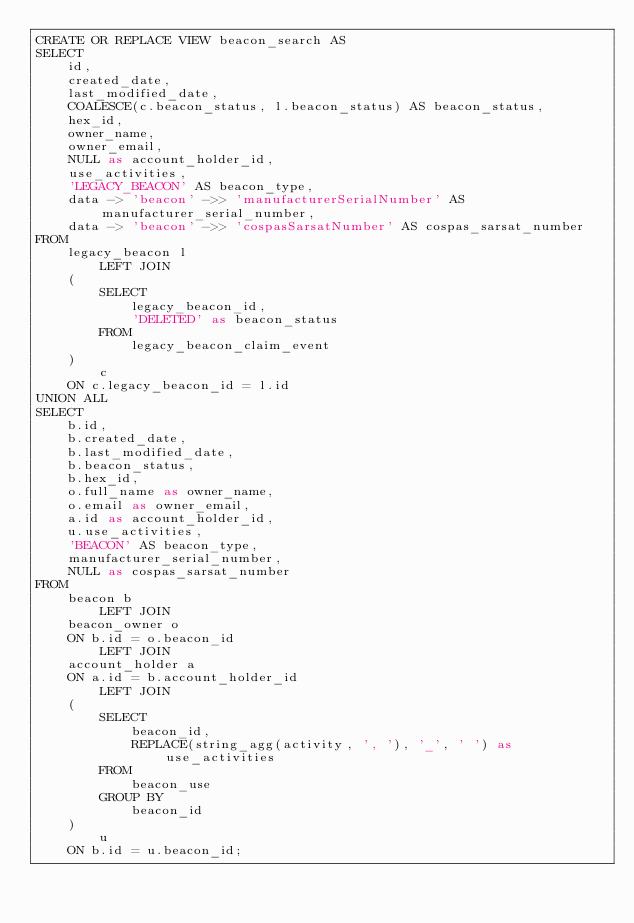<code> <loc_0><loc_0><loc_500><loc_500><_SQL_>CREATE OR REPLACE VIEW beacon_search AS
SELECT
    id,
    created_date,
    last_modified_date,
    COALESCE(c.beacon_status, l.beacon_status) AS beacon_status,
    hex_id,
    owner_name,
    owner_email,
    NULL as account_holder_id,
    use_activities,
    'LEGACY_BEACON' AS beacon_type,
    data -> 'beacon' ->> 'manufacturerSerialNumber' AS manufacturer_serial_number,
    data -> 'beacon' ->> 'cospasSarsatNumber' AS cospas_sarsat_number
FROM
    legacy_beacon l
        LEFT JOIN
    (
        SELECT
            legacy_beacon_id,
            'DELETED' as beacon_status
        FROM
            legacy_beacon_claim_event
    )
        c
    ON c.legacy_beacon_id = l.id
UNION ALL
SELECT
    b.id,
    b.created_date,
    b.last_modified_date,
    b.beacon_status,
    b.hex_id,
    o.full_name as owner_name,
    o.email as owner_email,
    a.id as account_holder_id,
    u.use_activities,
    'BEACON' AS beacon_type,
    manufacturer_serial_number,
    NULL as cospas_sarsat_number
FROM
    beacon b
        LEFT JOIN
    beacon_owner o
    ON b.id = o.beacon_id
        LEFT JOIN
    account_holder a
    ON a.id = b.account_holder_id
        LEFT JOIN
    (
        SELECT
            beacon_id,
            REPLACE(string_agg(activity, ', '), '_', ' ') as use_activities
        FROM
            beacon_use
        GROUP BY
            beacon_id
    )
        u
    ON b.id = u.beacon_id;
</code> 